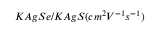<formula> <loc_0><loc_0><loc_500><loc_500>K A g S e / K A g S ( c m ^ { 2 } V ^ { - 1 } s ^ { - 1 } )</formula> 